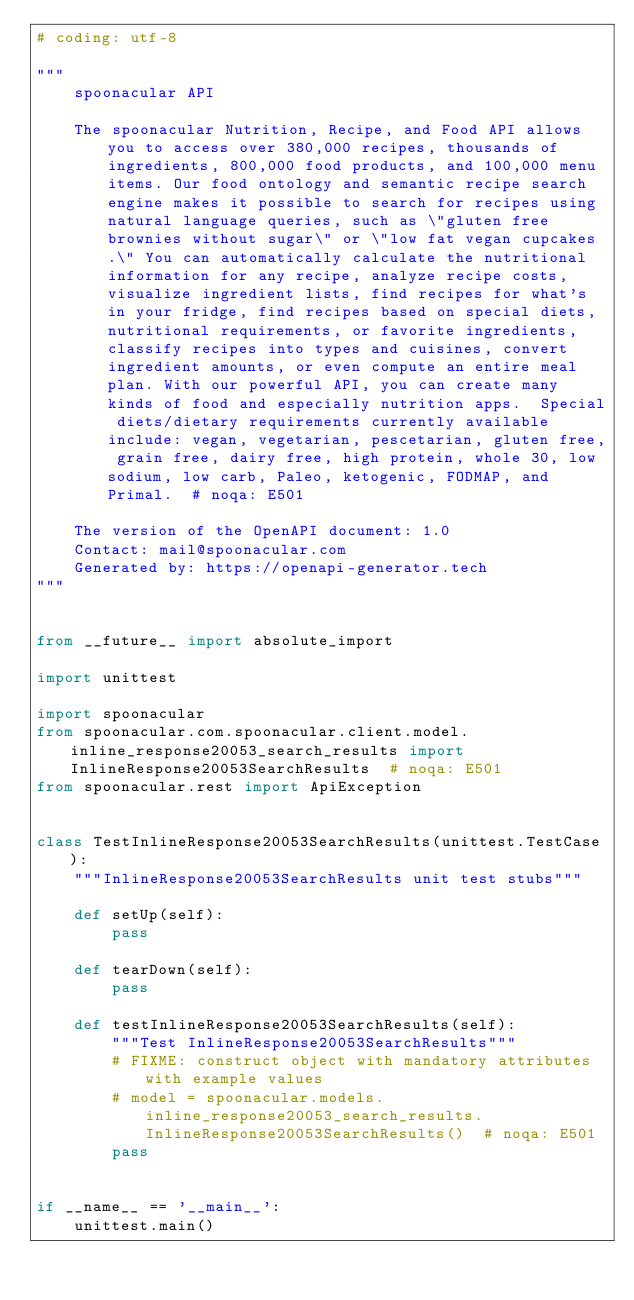<code> <loc_0><loc_0><loc_500><loc_500><_Python_># coding: utf-8

"""
    spoonacular API

    The spoonacular Nutrition, Recipe, and Food API allows you to access over 380,000 recipes, thousands of ingredients, 800,000 food products, and 100,000 menu items. Our food ontology and semantic recipe search engine makes it possible to search for recipes using natural language queries, such as \"gluten free brownies without sugar\" or \"low fat vegan cupcakes.\" You can automatically calculate the nutritional information for any recipe, analyze recipe costs, visualize ingredient lists, find recipes for what's in your fridge, find recipes based on special diets, nutritional requirements, or favorite ingredients, classify recipes into types and cuisines, convert ingredient amounts, or even compute an entire meal plan. With our powerful API, you can create many kinds of food and especially nutrition apps.  Special diets/dietary requirements currently available include: vegan, vegetarian, pescetarian, gluten free, grain free, dairy free, high protein, whole 30, low sodium, low carb, Paleo, ketogenic, FODMAP, and Primal.  # noqa: E501

    The version of the OpenAPI document: 1.0
    Contact: mail@spoonacular.com
    Generated by: https://openapi-generator.tech
"""


from __future__ import absolute_import

import unittest

import spoonacular
from spoonacular.com.spoonacular.client.model.inline_response20053_search_results import InlineResponse20053SearchResults  # noqa: E501
from spoonacular.rest import ApiException


class TestInlineResponse20053SearchResults(unittest.TestCase):
    """InlineResponse20053SearchResults unit test stubs"""

    def setUp(self):
        pass

    def tearDown(self):
        pass

    def testInlineResponse20053SearchResults(self):
        """Test InlineResponse20053SearchResults"""
        # FIXME: construct object with mandatory attributes with example values
        # model = spoonacular.models.inline_response20053_search_results.InlineResponse20053SearchResults()  # noqa: E501
        pass


if __name__ == '__main__':
    unittest.main()
</code> 